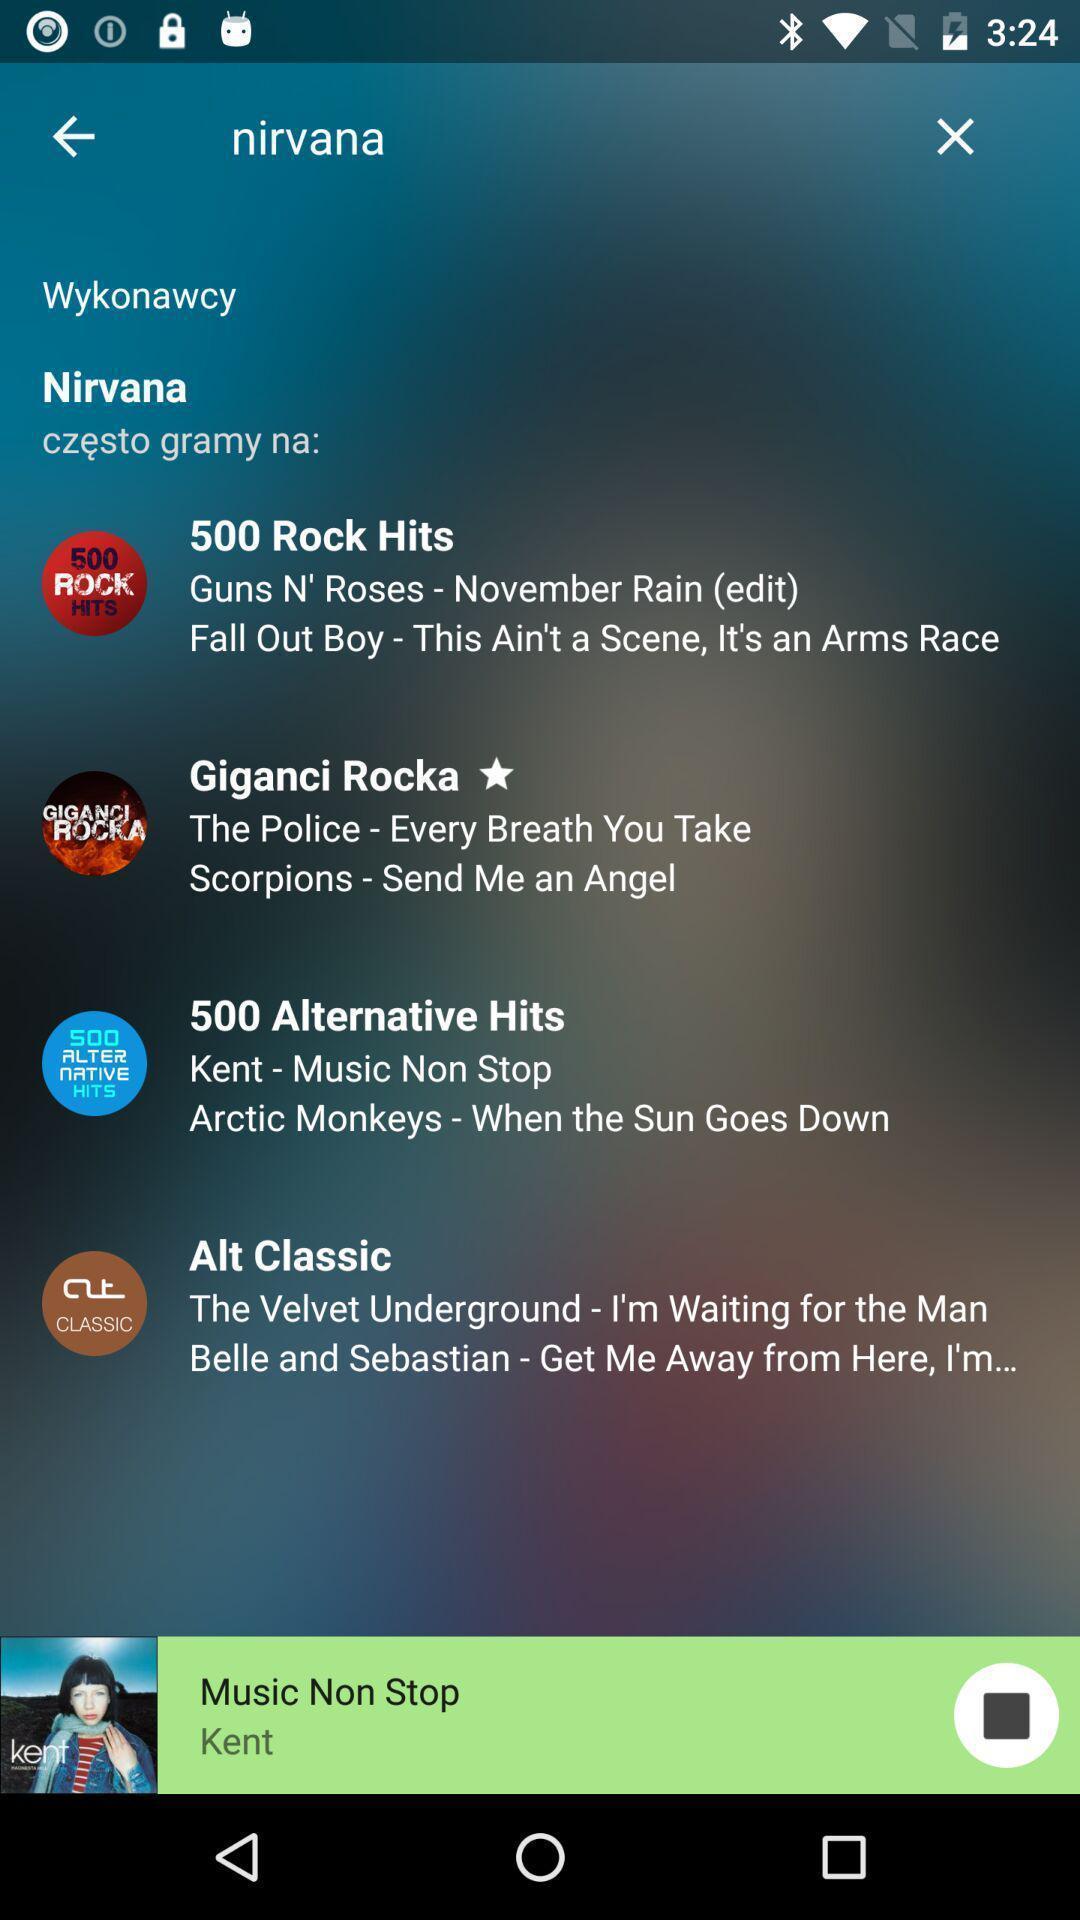Provide a detailed account of this screenshot. Page shows about the open fm app. 